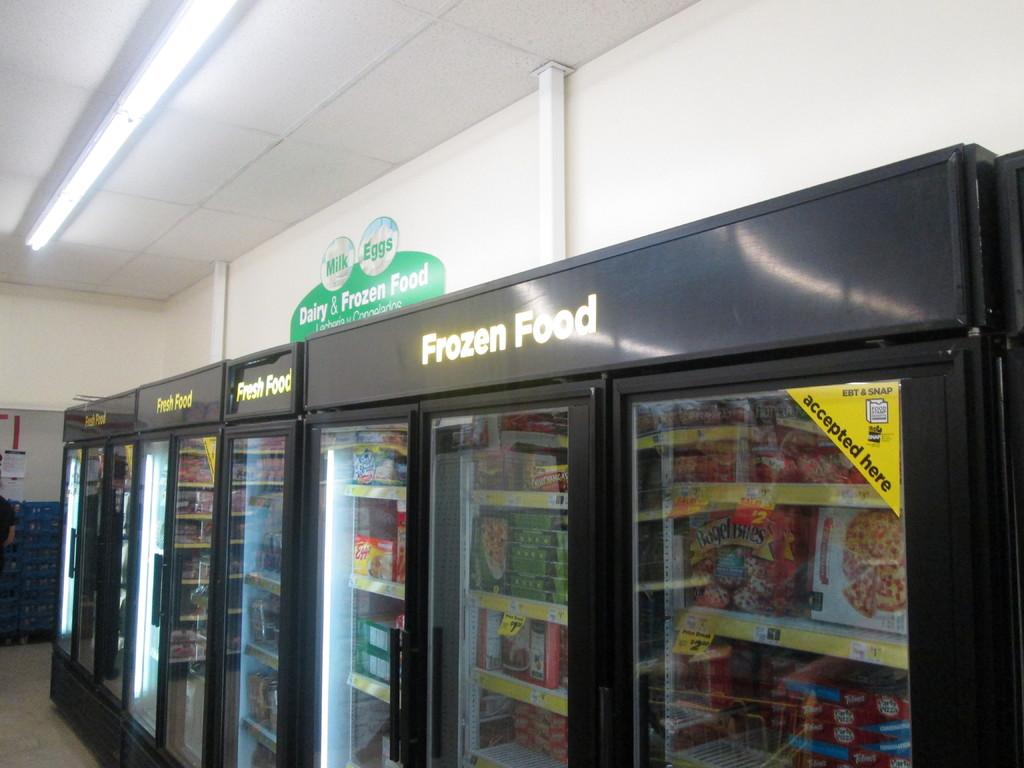What section is this?
Ensure brevity in your answer.  Frozen food. 